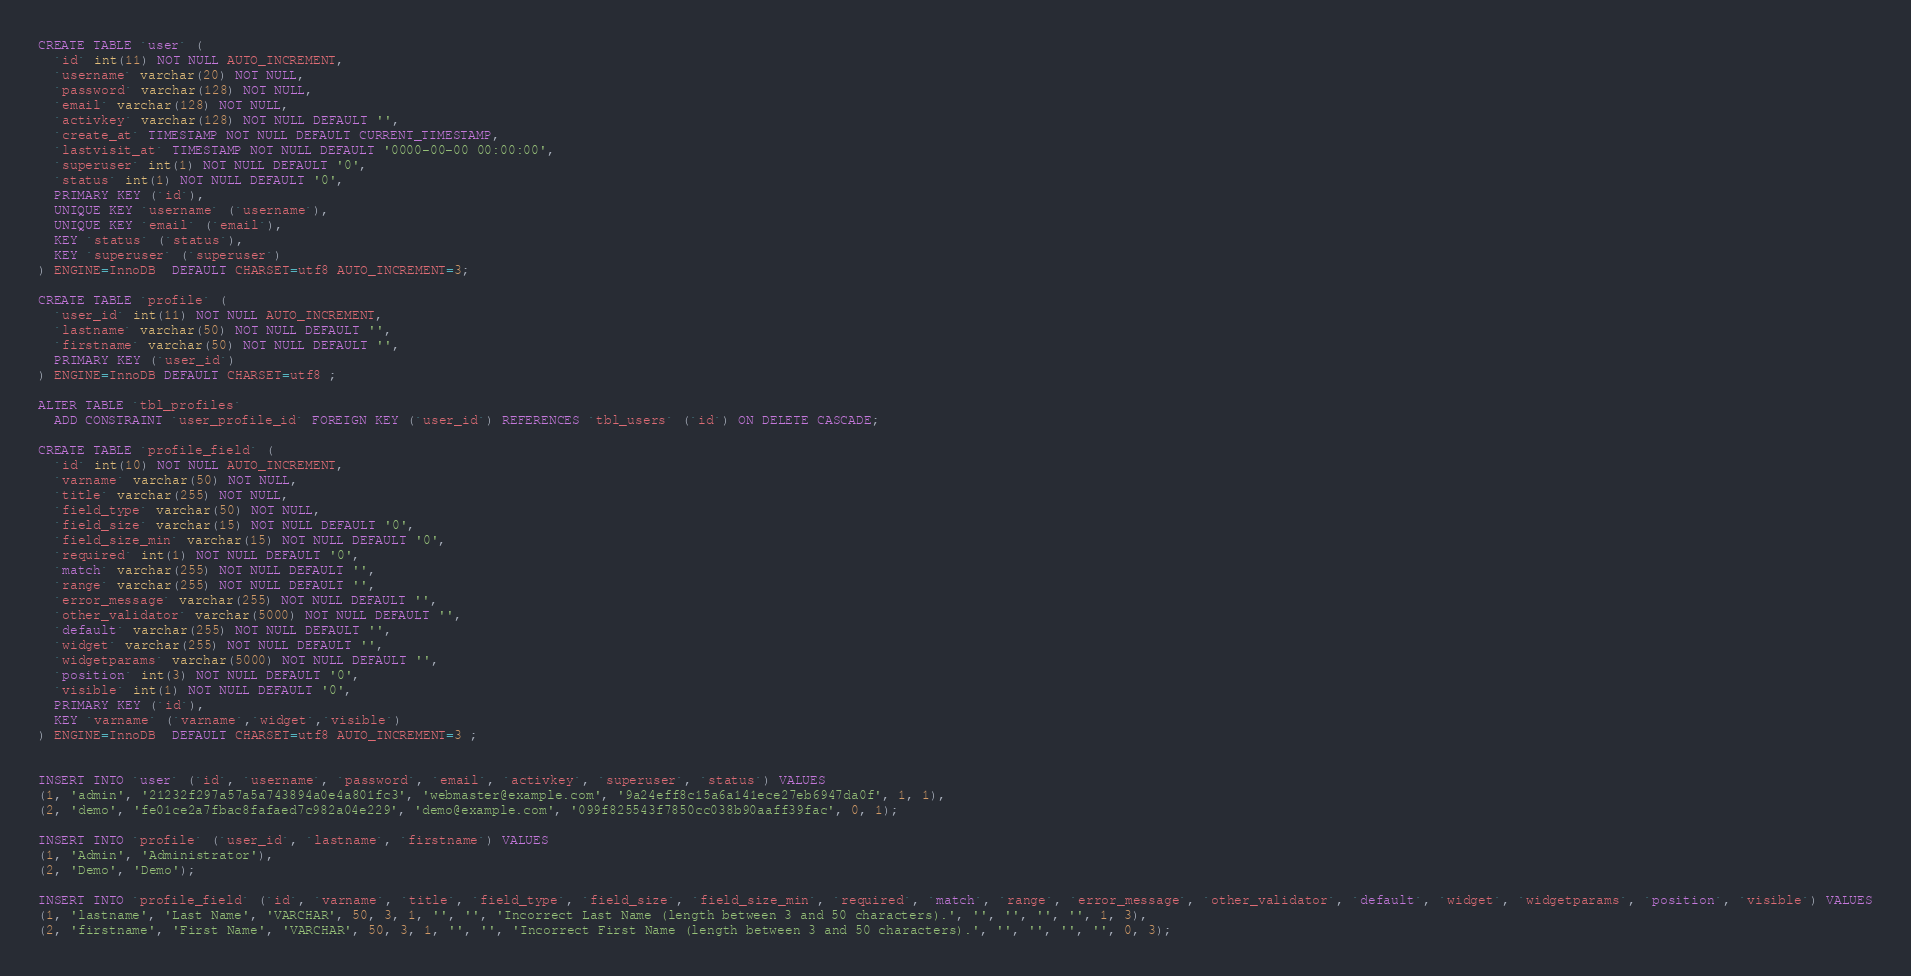Convert code to text. <code><loc_0><loc_0><loc_500><loc_500><_SQL_>CREATE TABLE `user` (
  `id` int(11) NOT NULL AUTO_INCREMENT,
  `username` varchar(20) NOT NULL,
  `password` varchar(128) NOT NULL,
  `email` varchar(128) NOT NULL,
  `activkey` varchar(128) NOT NULL DEFAULT '',
  `create_at` TIMESTAMP NOT NULL DEFAULT CURRENT_TIMESTAMP,
  `lastvisit_at` TIMESTAMP NOT NULL DEFAULT '0000-00-00 00:00:00',
  `superuser` int(1) NOT NULL DEFAULT '0',
  `status` int(1) NOT NULL DEFAULT '0',
  PRIMARY KEY (`id`),
  UNIQUE KEY `username` (`username`),
  UNIQUE KEY `email` (`email`),
  KEY `status` (`status`),
  KEY `superuser` (`superuser`)
) ENGINE=InnoDB  DEFAULT CHARSET=utf8 AUTO_INCREMENT=3;

CREATE TABLE `profile` (
  `user_id` int(11) NOT NULL AUTO_INCREMENT,
  `lastname` varchar(50) NOT NULL DEFAULT '',
  `firstname` varchar(50) NOT NULL DEFAULT '',
  PRIMARY KEY (`user_id`)
) ENGINE=InnoDB DEFAULT CHARSET=utf8 ;

ALTER TABLE `tbl_profiles`
  ADD CONSTRAINT `user_profile_id` FOREIGN KEY (`user_id`) REFERENCES `tbl_users` (`id`) ON DELETE CASCADE;

CREATE TABLE `profile_field` (
  `id` int(10) NOT NULL AUTO_INCREMENT,
  `varname` varchar(50) NOT NULL,
  `title` varchar(255) NOT NULL,
  `field_type` varchar(50) NOT NULL,
  `field_size` varchar(15) NOT NULL DEFAULT '0',
  `field_size_min` varchar(15) NOT NULL DEFAULT '0',
  `required` int(1) NOT NULL DEFAULT '0',
  `match` varchar(255) NOT NULL DEFAULT '',
  `range` varchar(255) NOT NULL DEFAULT '',
  `error_message` varchar(255) NOT NULL DEFAULT '',
  `other_validator` varchar(5000) NOT NULL DEFAULT '',
  `default` varchar(255) NOT NULL DEFAULT '',
  `widget` varchar(255) NOT NULL DEFAULT '',
  `widgetparams` varchar(5000) NOT NULL DEFAULT '',
  `position` int(3) NOT NULL DEFAULT '0',
  `visible` int(1) NOT NULL DEFAULT '0',
  PRIMARY KEY (`id`),
  KEY `varname` (`varname`,`widget`,`visible`)
) ENGINE=InnoDB  DEFAULT CHARSET=utf8 AUTO_INCREMENT=3 ;


INSERT INTO `user` (`id`, `username`, `password`, `email`, `activkey`, `superuser`, `status`) VALUES
(1, 'admin', '21232f297a57a5a743894a0e4a801fc3', 'webmaster@example.com', '9a24eff8c15a6a141ece27eb6947da0f', 1, 1),
(2, 'demo', 'fe01ce2a7fbac8fafaed7c982a04e229', 'demo@example.com', '099f825543f7850cc038b90aaff39fac', 0, 1);

INSERT INTO `profile` (`user_id`, `lastname`, `firstname`) VALUES
(1, 'Admin', 'Administrator'),
(2, 'Demo', 'Demo');

INSERT INTO `profile_field` (`id`, `varname`, `title`, `field_type`, `field_size`, `field_size_min`, `required`, `match`, `range`, `error_message`, `other_validator`, `default`, `widget`, `widgetparams`, `position`, `visible`) VALUES
(1, 'lastname', 'Last Name', 'VARCHAR', 50, 3, 1, '', '', 'Incorrect Last Name (length between 3 and 50 characters).', '', '', '', '', 1, 3),
(2, 'firstname', 'First Name', 'VARCHAR', 50, 3, 1, '', '', 'Incorrect First Name (length between 3 and 50 characters).', '', '', '', '', 0, 3);</code> 